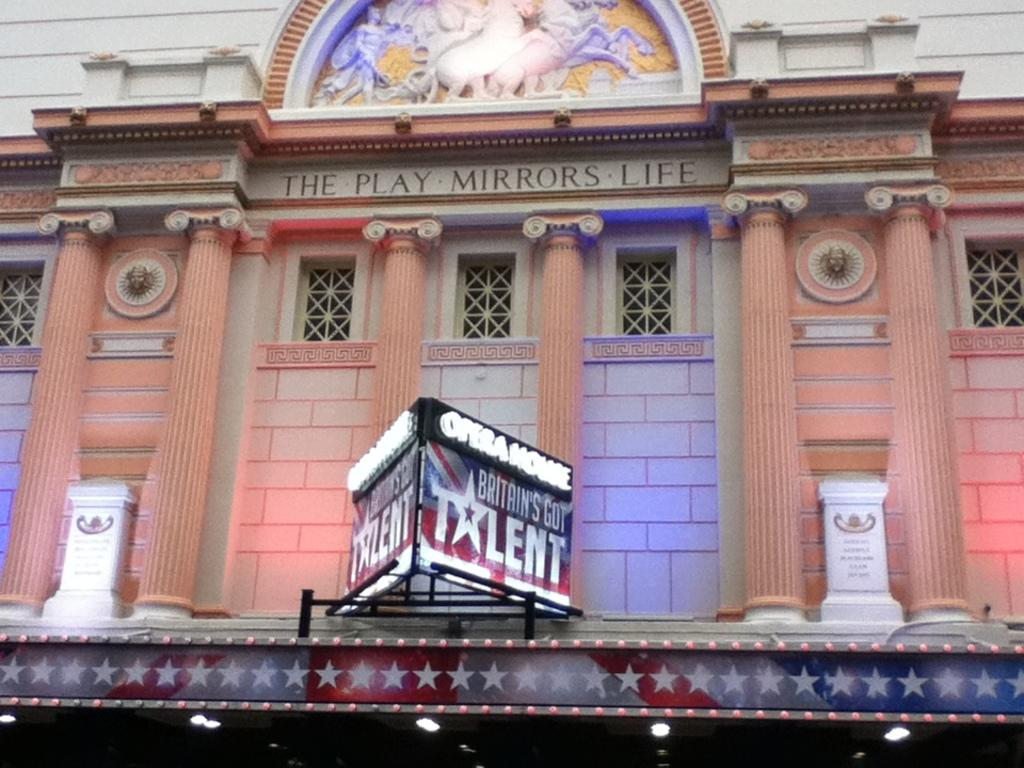What is the color of the building in the image? The building in the image is brown. What architectural features can be seen on the building? The building has windows and pillars. What is located in front of the building? There is an advertising board in front of the building. What type of mint is growing on the roof of the building in the image? There is no mint growing on the roof of the building in the image. 